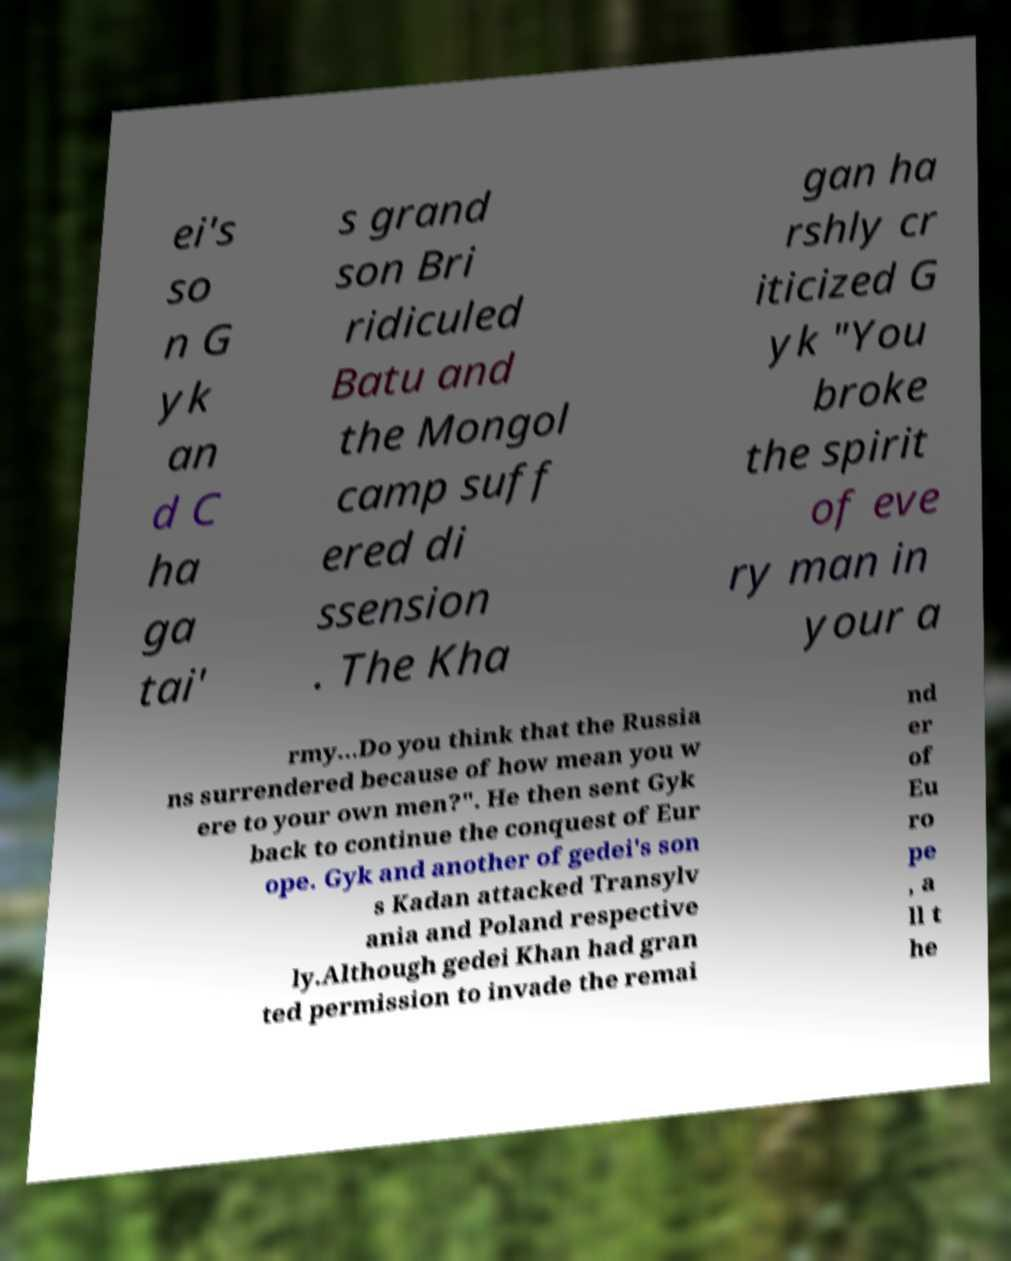Could you extract and type out the text from this image? ei's so n G yk an d C ha ga tai' s grand son Bri ridiculed Batu and the Mongol camp suff ered di ssension . The Kha gan ha rshly cr iticized G yk "You broke the spirit of eve ry man in your a rmy...Do you think that the Russia ns surrendered because of how mean you w ere to your own men?". He then sent Gyk back to continue the conquest of Eur ope. Gyk and another of gedei's son s Kadan attacked Transylv ania and Poland respective ly.Although gedei Khan had gran ted permission to invade the remai nd er of Eu ro pe , a ll t he 